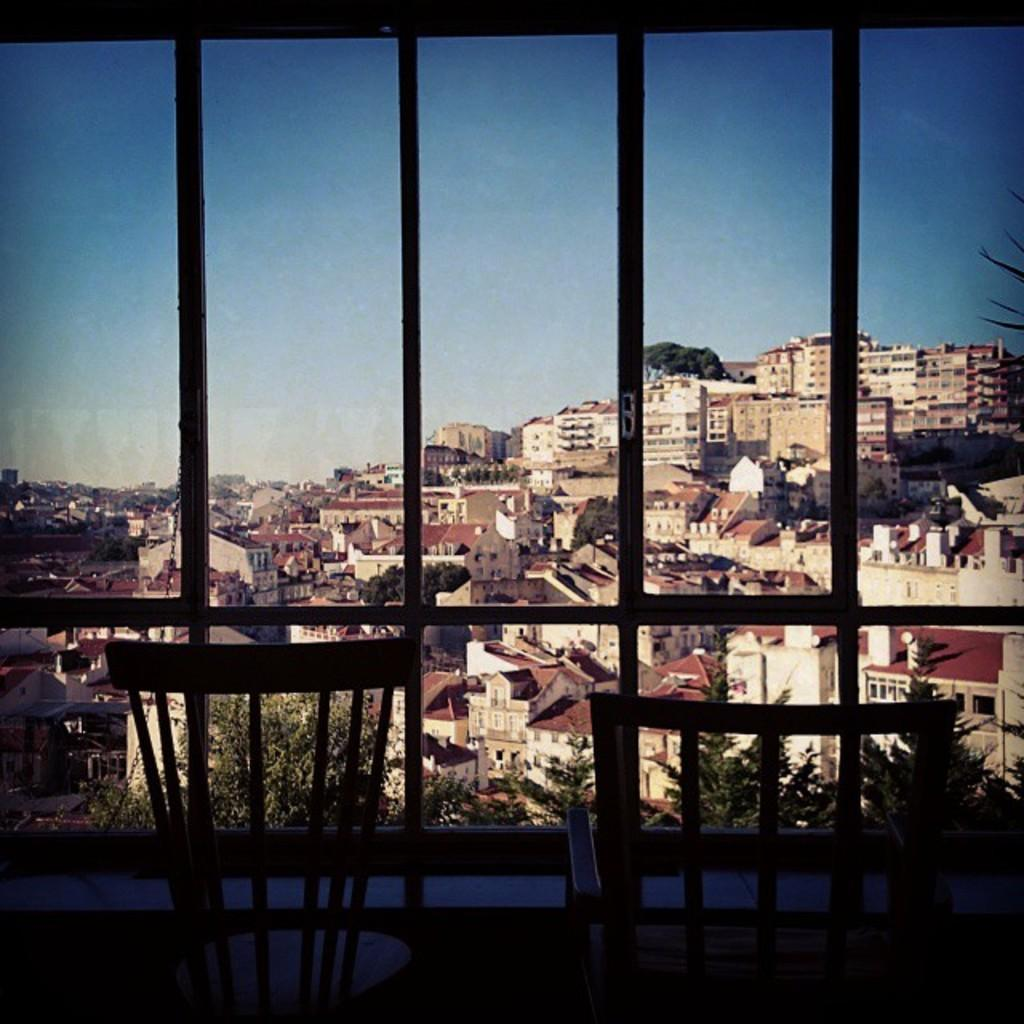What objects are in the front of the image? There are empty chairs in the front of the image. What can be seen in the center of the image? There is a window in the center of the image. What is visible through the window? Buildings and trees are visible through the window. Is there any greenery present in the image? Yes, there is a plant in front of the window. What language is being spoken by the feather in the image? There is no feather present in the image, and therefore no language being spoken. What type of competition is taking place in the image? There is no competition depicted in the image. 